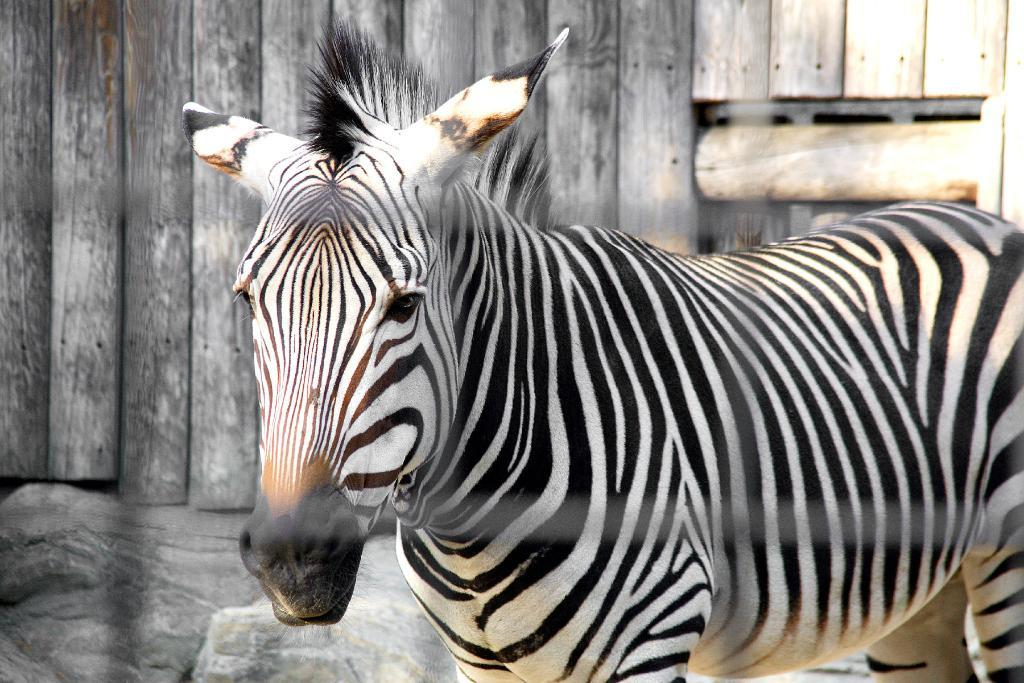What type of animal is in the image? There is a zebra in the image. What can be seen in the background of the image? There is a wall in the background of the image. What time does the watch show in the image? There is no watch present in the image. What type of rail can be seen in the image? There is no rail present in the image. 